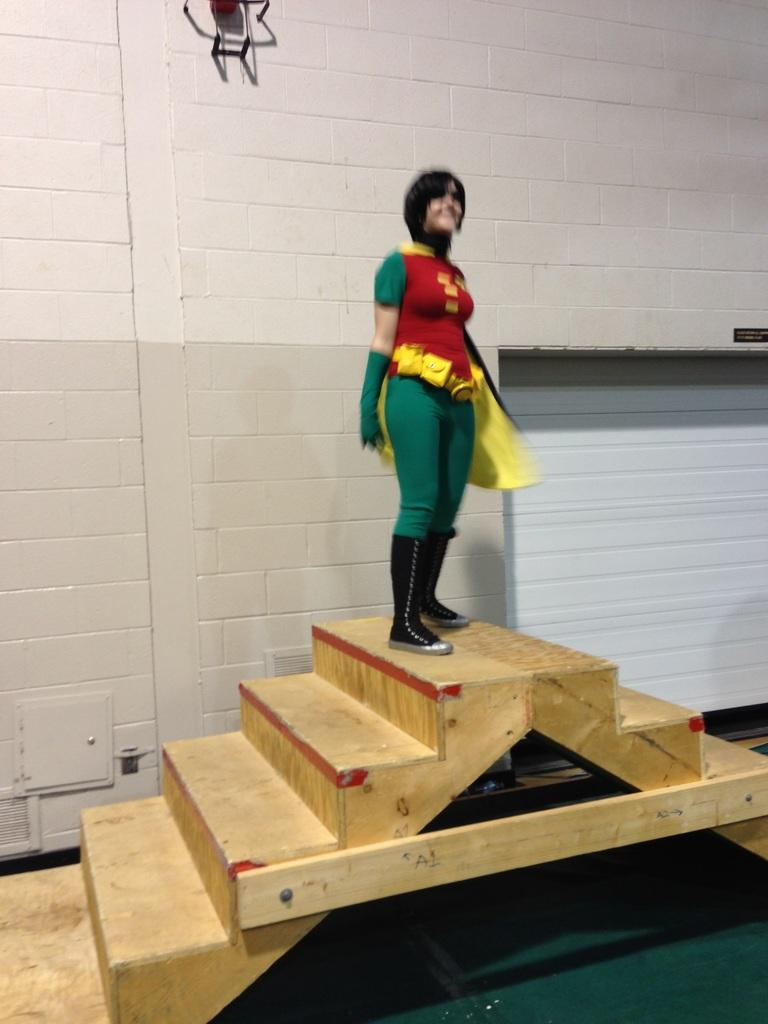What material are the steps made of in the image? The steps in the image are made of wood. Who is standing on the steps in the image? A woman is standing on the steps in the image. What is the woman wearing in the image? The woman is wearing different costumes in the image. What can be seen in the background of the image? There is a wall visible in the background of the image. What type of gold jewelry is the woman wearing in the image? There is no gold jewelry visible in the image. What part of the brain can be seen in the image? There is no part of the brain present in the image. 